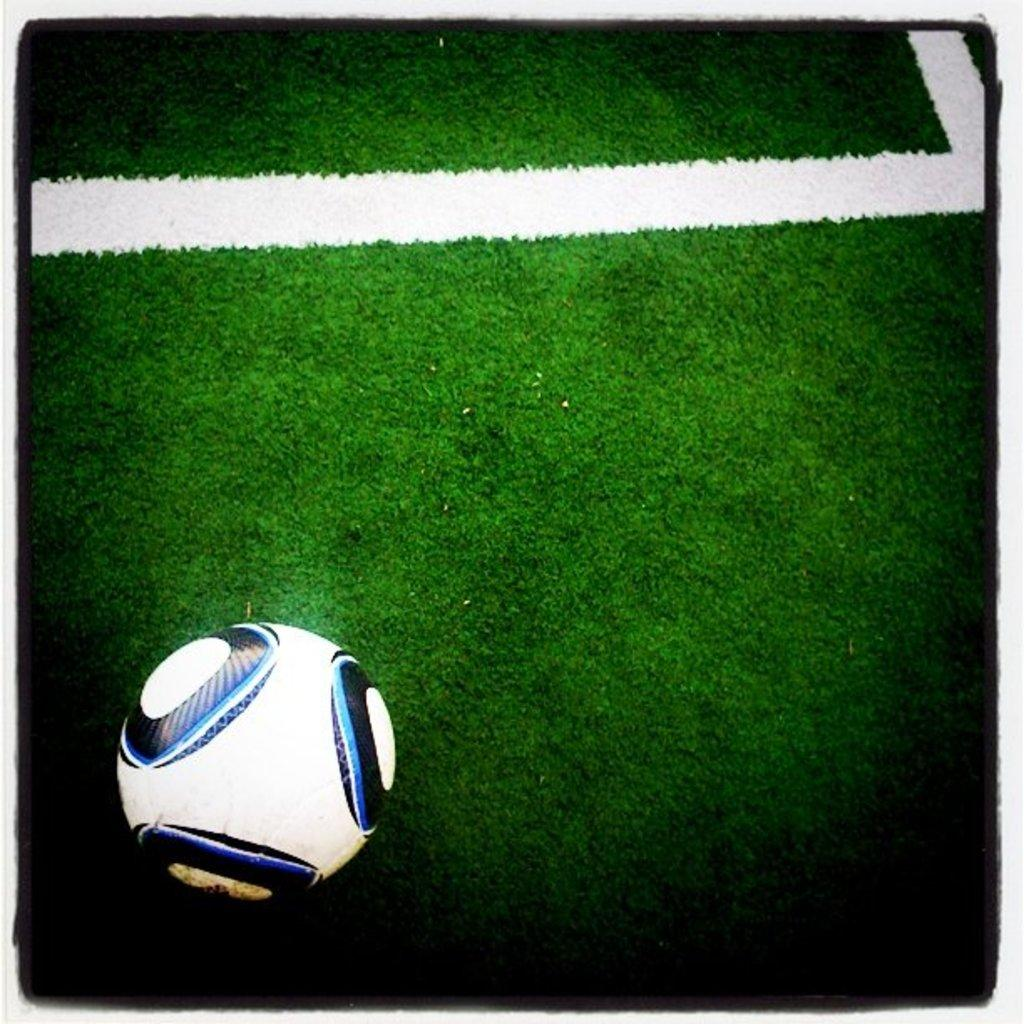What type of vegetation is present in the image? There is green grass in the image. What object can be seen on the grass? There is a football on the grass. What reward is being given to the person who smells the hill in the image? There is no hill or person smelling anything in the image. 